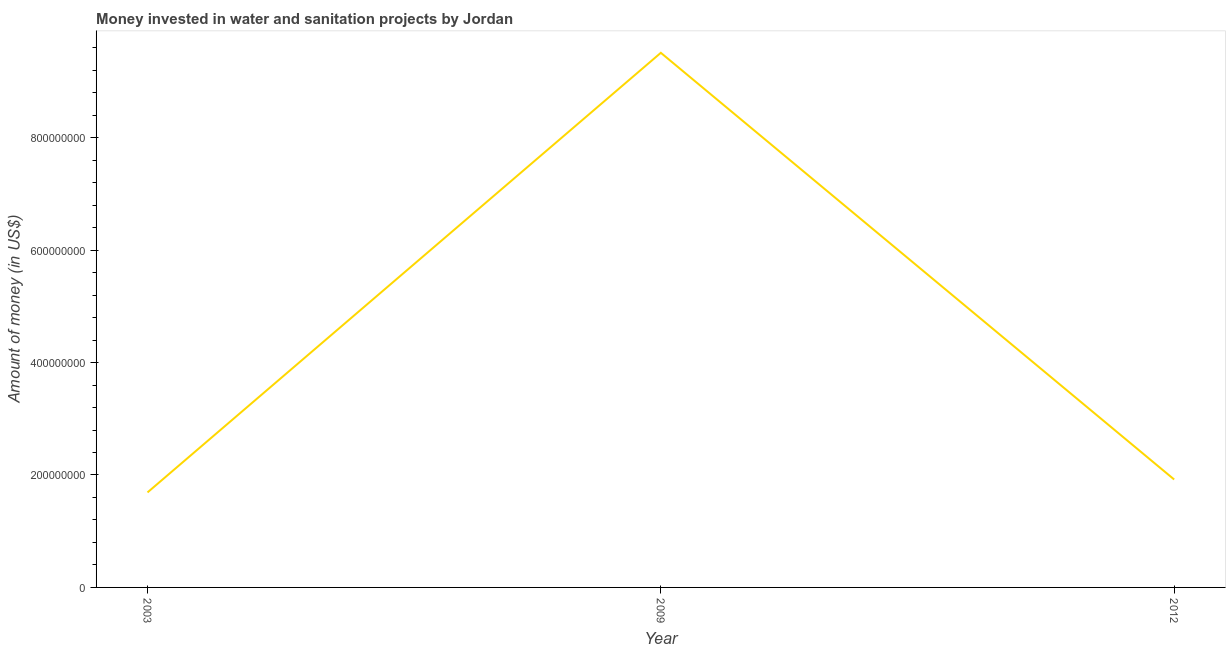What is the investment in 2012?
Make the answer very short. 1.92e+08. Across all years, what is the maximum investment?
Keep it short and to the point. 9.51e+08. Across all years, what is the minimum investment?
Give a very brief answer. 1.69e+08. What is the sum of the investment?
Your answer should be compact. 1.31e+09. What is the difference between the investment in 2009 and 2012?
Your answer should be very brief. 7.59e+08. What is the average investment per year?
Your response must be concise. 4.37e+08. What is the median investment?
Offer a very short reply. 1.92e+08. In how many years, is the investment greater than 120000000 US$?
Your response must be concise. 3. Do a majority of the years between 2003 and 2012 (inclusive) have investment greater than 40000000 US$?
Your response must be concise. Yes. What is the ratio of the investment in 2003 to that in 2009?
Your response must be concise. 0.18. Is the difference between the investment in 2009 and 2012 greater than the difference between any two years?
Your answer should be very brief. No. What is the difference between the highest and the second highest investment?
Provide a succinct answer. 7.59e+08. What is the difference between the highest and the lowest investment?
Provide a short and direct response. 7.82e+08. In how many years, is the investment greater than the average investment taken over all years?
Offer a terse response. 1. Are the values on the major ticks of Y-axis written in scientific E-notation?
Make the answer very short. No. Does the graph contain any zero values?
Offer a terse response. No. What is the title of the graph?
Provide a short and direct response. Money invested in water and sanitation projects by Jordan. What is the label or title of the X-axis?
Provide a succinct answer. Year. What is the label or title of the Y-axis?
Give a very brief answer. Amount of money (in US$). What is the Amount of money (in US$) in 2003?
Your answer should be very brief. 1.69e+08. What is the Amount of money (in US$) in 2009?
Provide a succinct answer. 9.51e+08. What is the Amount of money (in US$) of 2012?
Keep it short and to the point. 1.92e+08. What is the difference between the Amount of money (in US$) in 2003 and 2009?
Keep it short and to the point. -7.82e+08. What is the difference between the Amount of money (in US$) in 2003 and 2012?
Provide a short and direct response. -2.30e+07. What is the difference between the Amount of money (in US$) in 2009 and 2012?
Offer a terse response. 7.59e+08. What is the ratio of the Amount of money (in US$) in 2003 to that in 2009?
Make the answer very short. 0.18. What is the ratio of the Amount of money (in US$) in 2009 to that in 2012?
Offer a terse response. 4.95. 